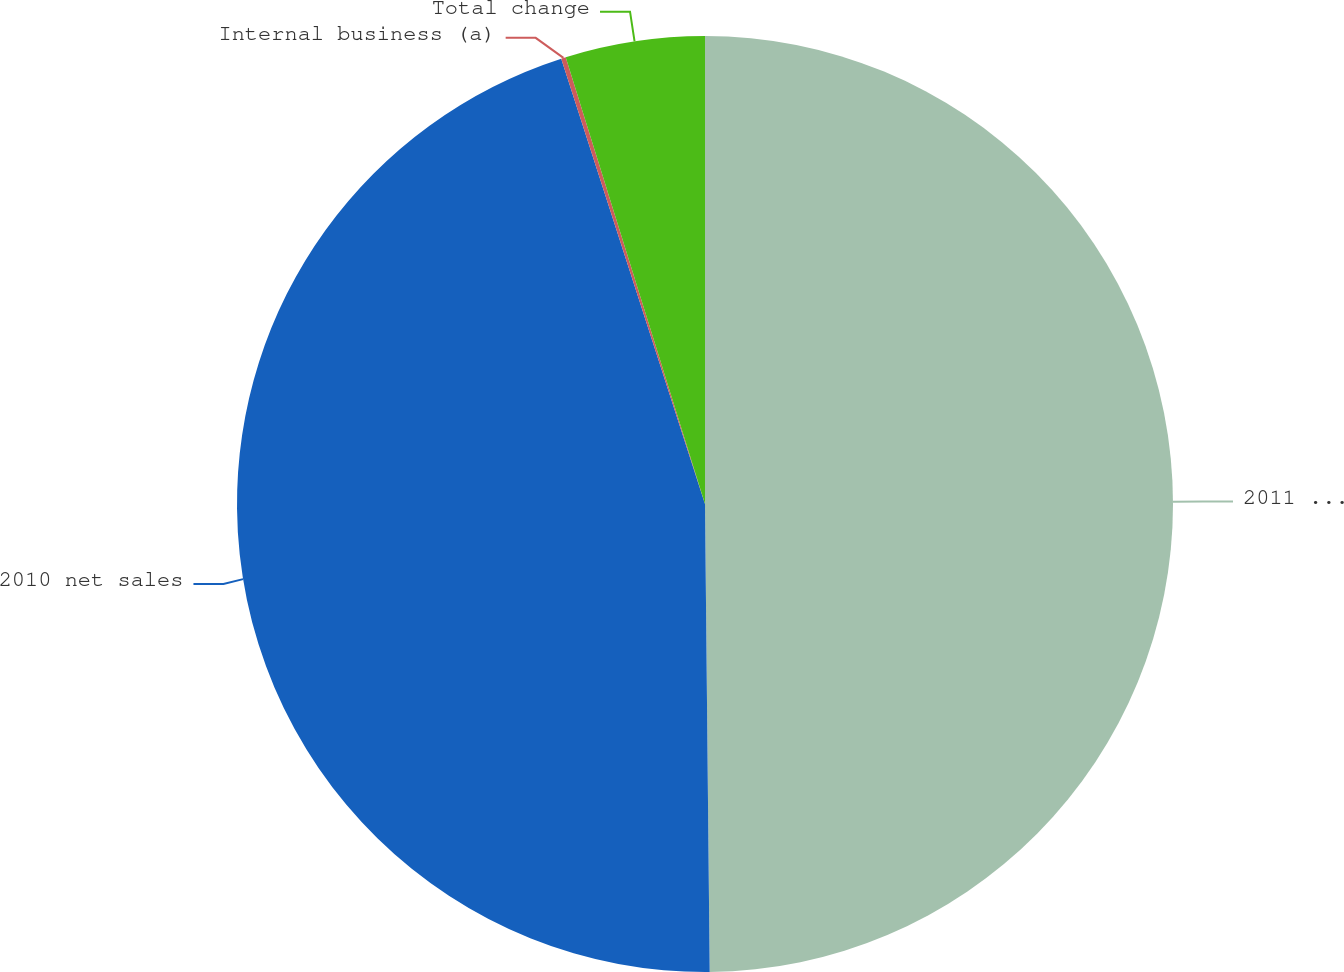Convert chart. <chart><loc_0><loc_0><loc_500><loc_500><pie_chart><fcel>2011 net sales<fcel>2010 net sales<fcel>Internal business (a)<fcel>Total change<nl><fcel>49.84%<fcel>45.19%<fcel>0.16%<fcel>4.81%<nl></chart> 